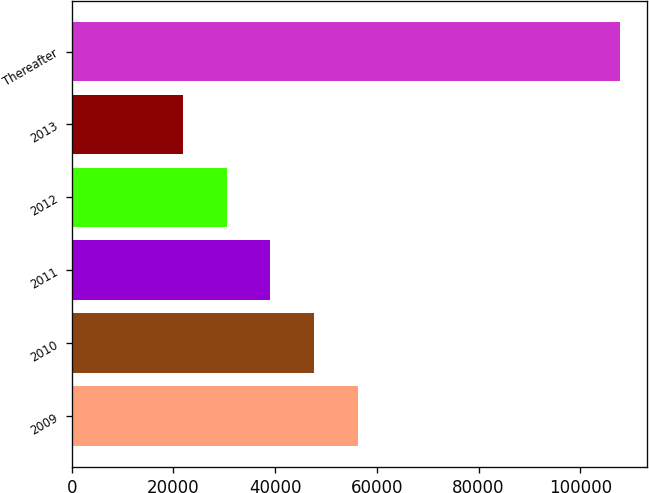Convert chart to OTSL. <chart><loc_0><loc_0><loc_500><loc_500><bar_chart><fcel>2009<fcel>2010<fcel>2011<fcel>2012<fcel>2013<fcel>Thereafter<nl><fcel>56251.2<fcel>47654.9<fcel>39058.6<fcel>30462.3<fcel>21866<fcel>107829<nl></chart> 